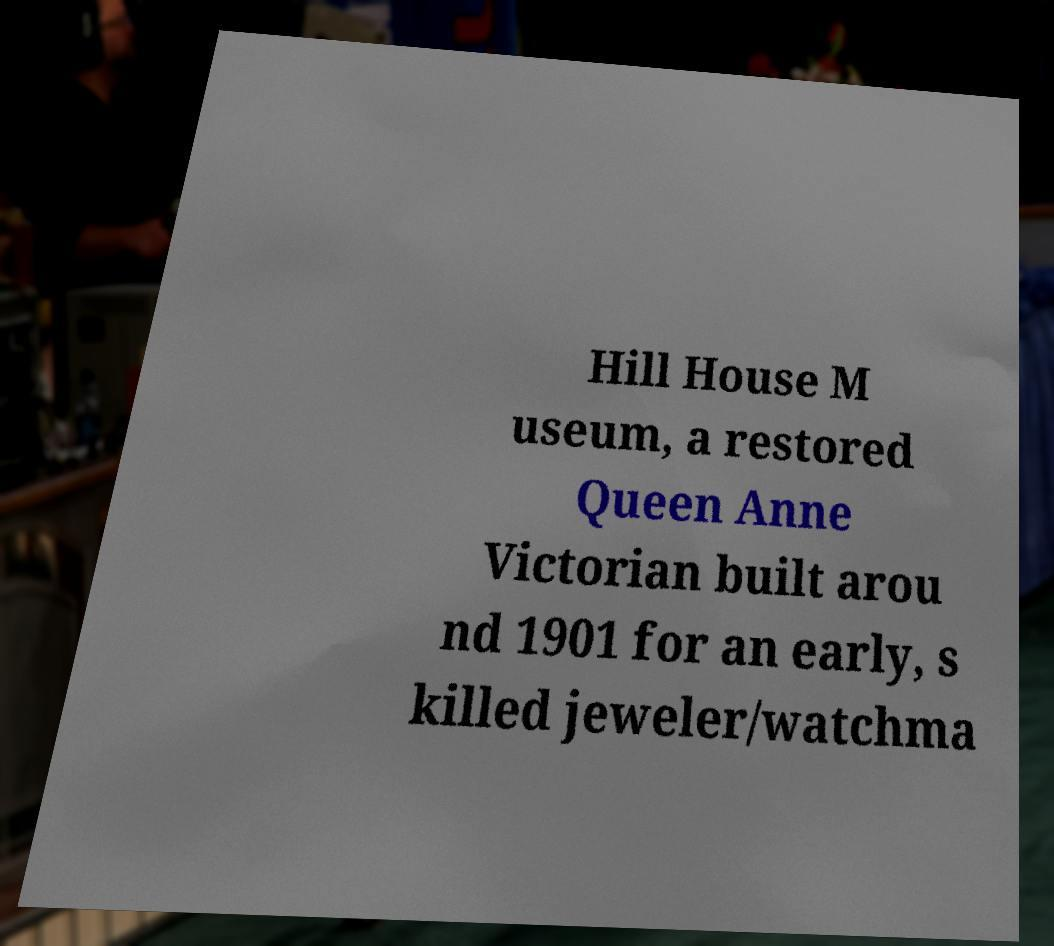Can you read and provide the text displayed in the image?This photo seems to have some interesting text. Can you extract and type it out for me? Hill House M useum, a restored Queen Anne Victorian built arou nd 1901 for an early, s killed jeweler/watchma 